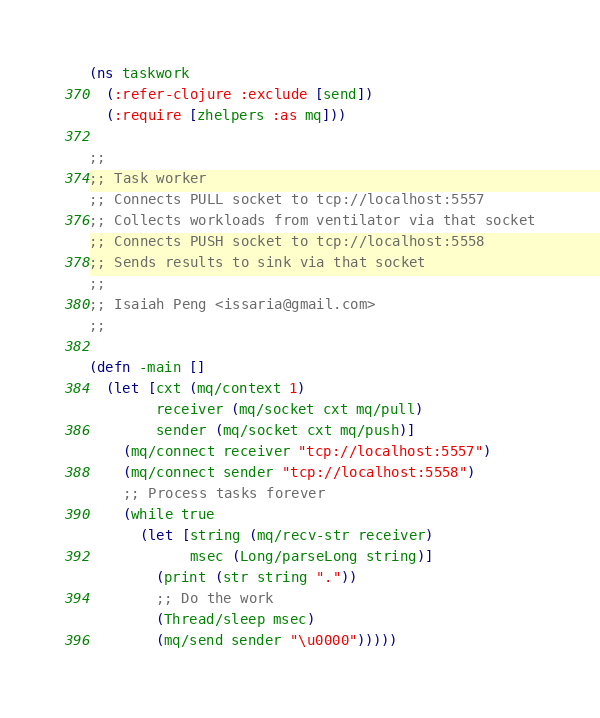Convert code to text. <code><loc_0><loc_0><loc_500><loc_500><_Clojure_>(ns taskwork
  (:refer-clojure :exclude [send])
  (:require [zhelpers :as mq]))

;;
;; Task worker
;; Connects PULL socket to tcp://localhost:5557
;; Collects workloads from ventilator via that socket
;; Connects PUSH socket to tcp://localhost:5558
;; Sends results to sink via that socket
;;
;; Isaiah Peng <issaria@gmail.com>
;;

(defn -main []
  (let [cxt (mq/context 1)
        receiver (mq/socket cxt mq/pull)
        sender (mq/socket cxt mq/push)]
    (mq/connect receiver "tcp://localhost:5557")
    (mq/connect sender "tcp://localhost:5558")
    ;; Process tasks forever
    (while true
      (let [string (mq/recv-str receiver)
            msec (Long/parseLong string)]
        (print (str string "."))
        ;; Do the work
        (Thread/sleep msec)
        (mq/send sender "\u0000")))))
</code> 